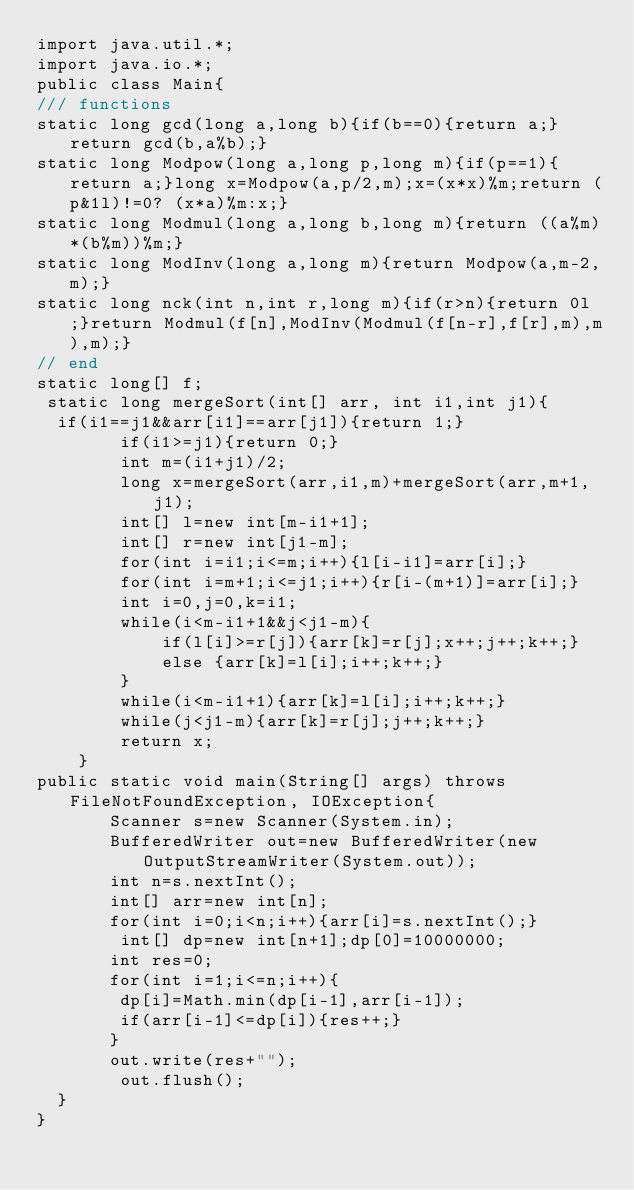Convert code to text. <code><loc_0><loc_0><loc_500><loc_500><_Java_>import java.util.*;
import java.io.*;
public class Main{
/// functions
static long gcd(long a,long b){if(b==0){return a;}return gcd(b,a%b);}
static long Modpow(long a,long p,long m){if(p==1){return a;}long x=Modpow(a,p/2,m);x=(x*x)%m;return (p&1l)!=0? (x*a)%m:x;}
static long Modmul(long a,long b,long m){return ((a%m)*(b%m))%m;}
static long ModInv(long a,long m){return Modpow(a,m-2,m);}
static long nck(int n,int r,long m){if(r>n){return 0l;}return Modmul(f[n],ModInv(Modmul(f[n-r],f[r],m),m),m);}
// end
static long[] f;
 static long mergeSort(int[] arr, int i1,int j1){
 	if(i1==j1&&arr[i1]==arr[j1]){return 1;}
        if(i1>=j1){return 0;}
        int m=(i1+j1)/2;
        long x=mergeSort(arr,i1,m)+mergeSort(arr,m+1,j1);
        int[] l=new int[m-i1+1];
        int[] r=new int[j1-m];
        for(int i=i1;i<=m;i++){l[i-i1]=arr[i];}
        for(int i=m+1;i<=j1;i++){r[i-(m+1)]=arr[i];}
        int i=0,j=0,k=i1;
        while(i<m-i1+1&&j<j1-m){
            if(l[i]>=r[j]){arr[k]=r[j];x++;j++;k++;}
            else {arr[k]=l[i];i++;k++;}
        }
        while(i<m-i1+1){arr[k]=l[i];i++;k++;}
        while(j<j1-m){arr[k]=r[j];j++;k++;}
        return x;
    }
public static void main(String[] args) throws FileNotFoundException, IOException{
       Scanner s=new Scanner(System.in);
       BufferedWriter out=new BufferedWriter(new OutputStreamWriter(System.out));
       int n=s.nextInt();
       int[] arr=new int[n];
       for(int i=0;i<n;i++){arr[i]=s.nextInt();}
       	int[] dp=new int[n+1];dp[0]=10000000;
       int res=0;
       for(int i=1;i<=n;i++){
       	dp[i]=Math.min(dp[i-1],arr[i-1]);
       	if(arr[i-1]<=dp[i]){res++;}
       }
       out.write(res+"");
        out.flush();
  }
}
</code> 